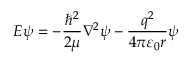<formula> <loc_0><loc_0><loc_500><loc_500>E \psi = - { \frac { \hbar { ^ } { 2 } } { 2 \mu } } \nabla ^ { 2 } \psi - { \frac { q ^ { 2 } } { 4 \pi \varepsilon _ { 0 } r } } \psi</formula> 